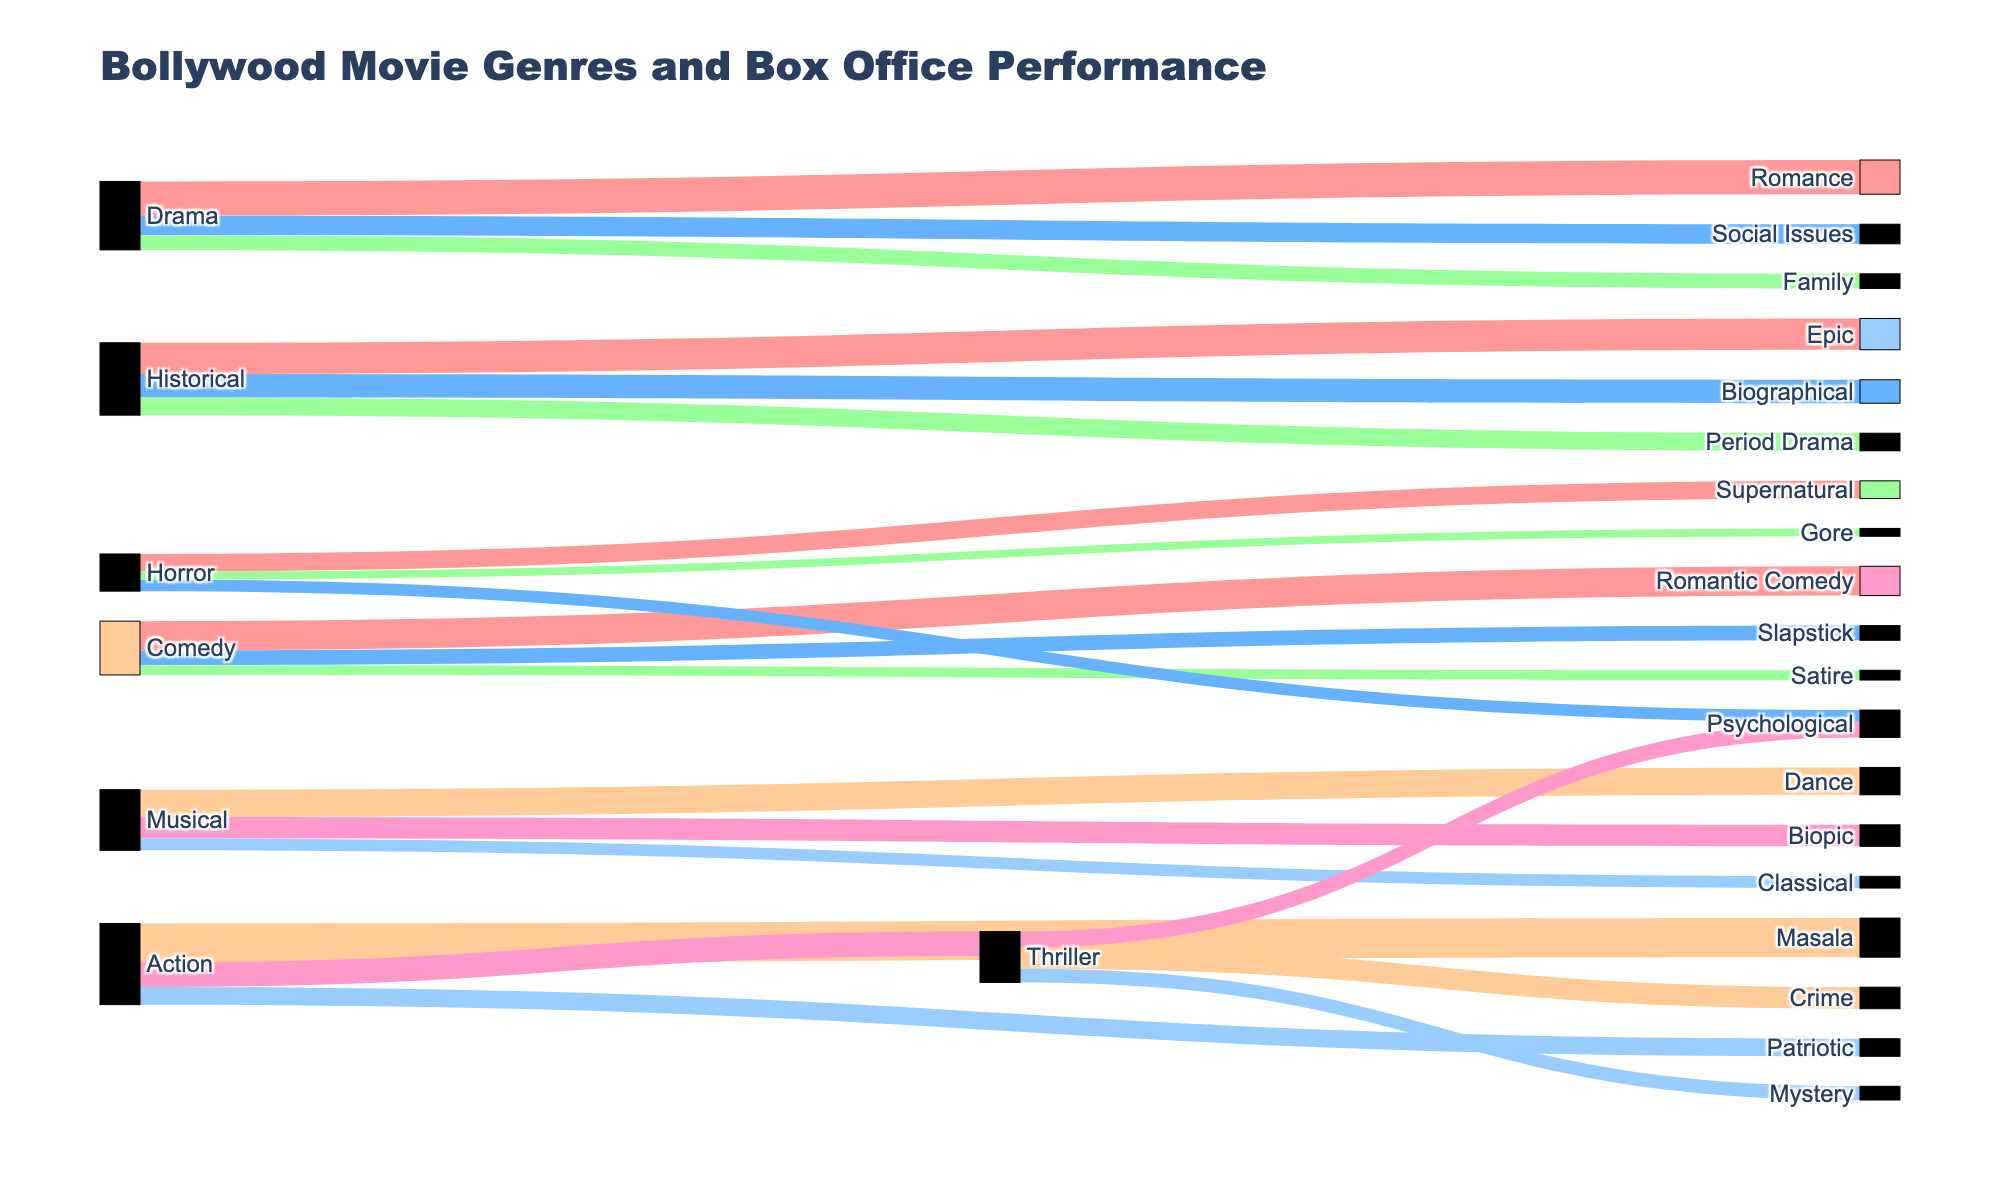what is the total box office performance of Drama movies? To find the total box-office performance of Drama movies, sum the values for Romance (350), Social Issues (200), and Family (150): 350 + 200 + 150 = 700
Answer: 700 which genre connected to Action movies has the highest box office performance? Action movies connect to Masala (400), Thriller (250), and Patriotic (180). Masala has the highest value at 400
Answer: Masala Compare the combined box office performance of Comedy and Horror genres. Which is higher? For Comedy, sum Romantic Comedy (300), Slapstick (150), and Satire (100): 300 + 150 + 100 = 550. For Horror, sum Supernatural (180), Psychological (120), and Gore (80): 180 + 120 + 80 = 380. Comedy (550) is higher than Horror (380)
Answer: Comedy What is the average box office performance of genres under Musical movies? Sum the values of Dance (280), Biopic (220), and Classical (120): 280 + 220 + 120 = 620. Divide by the number of genres (3) to get the average: 620 / 3 ≈ 206.67
Answer: 206.67 Which genre has the lowest box office performance contribution from Horror movies? Supernatural (180), Psychological (120), and Gore (80) are the genres under Horror. Gore has the lowest value at 80
Answer: Gore 